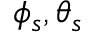<formula> <loc_0><loc_0><loc_500><loc_500>\phi _ { s } , \theta _ { s }</formula> 